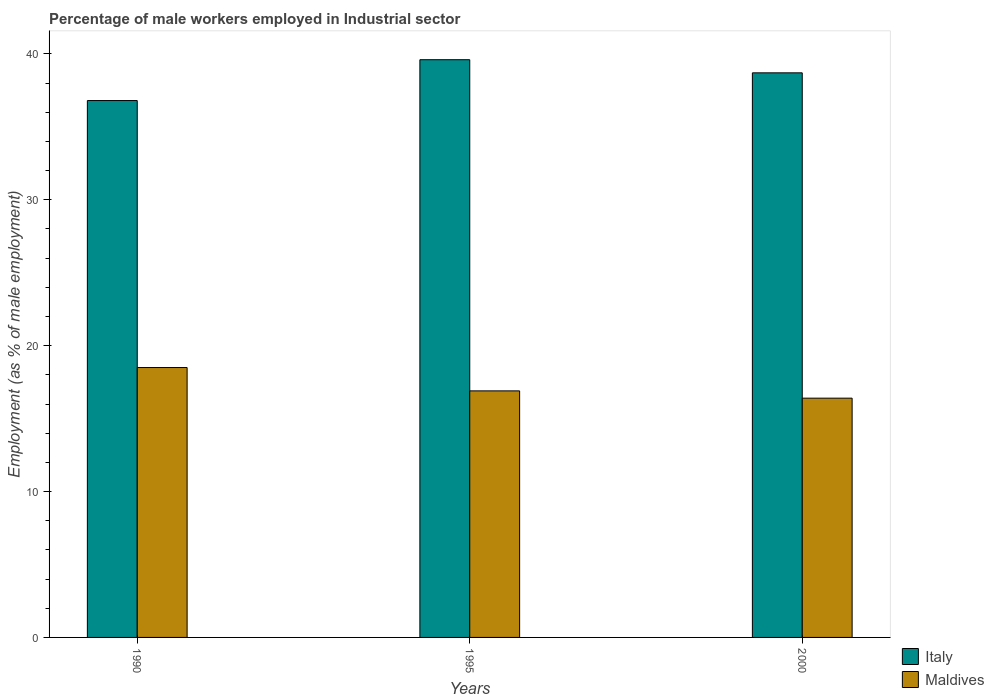How many different coloured bars are there?
Your response must be concise. 2. Are the number of bars per tick equal to the number of legend labels?
Ensure brevity in your answer.  Yes. Are the number of bars on each tick of the X-axis equal?
Keep it short and to the point. Yes. What is the label of the 1st group of bars from the left?
Make the answer very short. 1990. In how many cases, is the number of bars for a given year not equal to the number of legend labels?
Offer a terse response. 0. What is the percentage of male workers employed in Industrial sector in Italy in 1990?
Provide a succinct answer. 36.8. Across all years, what is the minimum percentage of male workers employed in Industrial sector in Italy?
Your response must be concise. 36.8. In which year was the percentage of male workers employed in Industrial sector in Maldives maximum?
Your answer should be very brief. 1990. In which year was the percentage of male workers employed in Industrial sector in Maldives minimum?
Offer a terse response. 2000. What is the total percentage of male workers employed in Industrial sector in Maldives in the graph?
Provide a short and direct response. 51.8. What is the difference between the percentage of male workers employed in Industrial sector in Italy in 1990 and that in 1995?
Your answer should be very brief. -2.8. What is the difference between the percentage of male workers employed in Industrial sector in Maldives in 2000 and the percentage of male workers employed in Industrial sector in Italy in 1990?
Provide a short and direct response. -20.4. What is the average percentage of male workers employed in Industrial sector in Italy per year?
Provide a short and direct response. 38.37. In the year 1990, what is the difference between the percentage of male workers employed in Industrial sector in Maldives and percentage of male workers employed in Industrial sector in Italy?
Ensure brevity in your answer.  -18.3. What is the ratio of the percentage of male workers employed in Industrial sector in Maldives in 1990 to that in 2000?
Provide a succinct answer. 1.13. Is the percentage of male workers employed in Industrial sector in Italy in 1990 less than that in 2000?
Keep it short and to the point. Yes. What is the difference between the highest and the second highest percentage of male workers employed in Industrial sector in Italy?
Make the answer very short. 0.9. What is the difference between the highest and the lowest percentage of male workers employed in Industrial sector in Maldives?
Your answer should be very brief. 2.1. What does the 2nd bar from the left in 2000 represents?
Provide a succinct answer. Maldives. What does the 1st bar from the right in 1995 represents?
Provide a short and direct response. Maldives. How many bars are there?
Your answer should be compact. 6. Are the values on the major ticks of Y-axis written in scientific E-notation?
Offer a terse response. No. Where does the legend appear in the graph?
Make the answer very short. Bottom right. How many legend labels are there?
Give a very brief answer. 2. What is the title of the graph?
Your answer should be very brief. Percentage of male workers employed in Industrial sector. Does "Mali" appear as one of the legend labels in the graph?
Provide a short and direct response. No. What is the label or title of the X-axis?
Keep it short and to the point. Years. What is the label or title of the Y-axis?
Offer a very short reply. Employment (as % of male employment). What is the Employment (as % of male employment) of Italy in 1990?
Keep it short and to the point. 36.8. What is the Employment (as % of male employment) in Italy in 1995?
Your answer should be compact. 39.6. What is the Employment (as % of male employment) in Maldives in 1995?
Your response must be concise. 16.9. What is the Employment (as % of male employment) in Italy in 2000?
Give a very brief answer. 38.7. What is the Employment (as % of male employment) of Maldives in 2000?
Offer a very short reply. 16.4. Across all years, what is the maximum Employment (as % of male employment) of Italy?
Keep it short and to the point. 39.6. Across all years, what is the minimum Employment (as % of male employment) of Italy?
Ensure brevity in your answer.  36.8. Across all years, what is the minimum Employment (as % of male employment) in Maldives?
Your response must be concise. 16.4. What is the total Employment (as % of male employment) of Italy in the graph?
Your answer should be very brief. 115.1. What is the total Employment (as % of male employment) in Maldives in the graph?
Your response must be concise. 51.8. What is the difference between the Employment (as % of male employment) of Maldives in 1990 and that in 1995?
Your answer should be compact. 1.6. What is the difference between the Employment (as % of male employment) in Italy in 1990 and that in 2000?
Make the answer very short. -1.9. What is the difference between the Employment (as % of male employment) of Maldives in 1990 and that in 2000?
Offer a very short reply. 2.1. What is the difference between the Employment (as % of male employment) in Maldives in 1995 and that in 2000?
Offer a very short reply. 0.5. What is the difference between the Employment (as % of male employment) in Italy in 1990 and the Employment (as % of male employment) in Maldives in 2000?
Offer a very short reply. 20.4. What is the difference between the Employment (as % of male employment) in Italy in 1995 and the Employment (as % of male employment) in Maldives in 2000?
Keep it short and to the point. 23.2. What is the average Employment (as % of male employment) in Italy per year?
Provide a short and direct response. 38.37. What is the average Employment (as % of male employment) in Maldives per year?
Offer a terse response. 17.27. In the year 1995, what is the difference between the Employment (as % of male employment) of Italy and Employment (as % of male employment) of Maldives?
Your answer should be very brief. 22.7. In the year 2000, what is the difference between the Employment (as % of male employment) of Italy and Employment (as % of male employment) of Maldives?
Provide a succinct answer. 22.3. What is the ratio of the Employment (as % of male employment) in Italy in 1990 to that in 1995?
Your answer should be very brief. 0.93. What is the ratio of the Employment (as % of male employment) of Maldives in 1990 to that in 1995?
Offer a very short reply. 1.09. What is the ratio of the Employment (as % of male employment) in Italy in 1990 to that in 2000?
Provide a succinct answer. 0.95. What is the ratio of the Employment (as % of male employment) in Maldives in 1990 to that in 2000?
Make the answer very short. 1.13. What is the ratio of the Employment (as % of male employment) of Italy in 1995 to that in 2000?
Keep it short and to the point. 1.02. What is the ratio of the Employment (as % of male employment) in Maldives in 1995 to that in 2000?
Offer a very short reply. 1.03. What is the difference between the highest and the second highest Employment (as % of male employment) of Italy?
Your response must be concise. 0.9. 